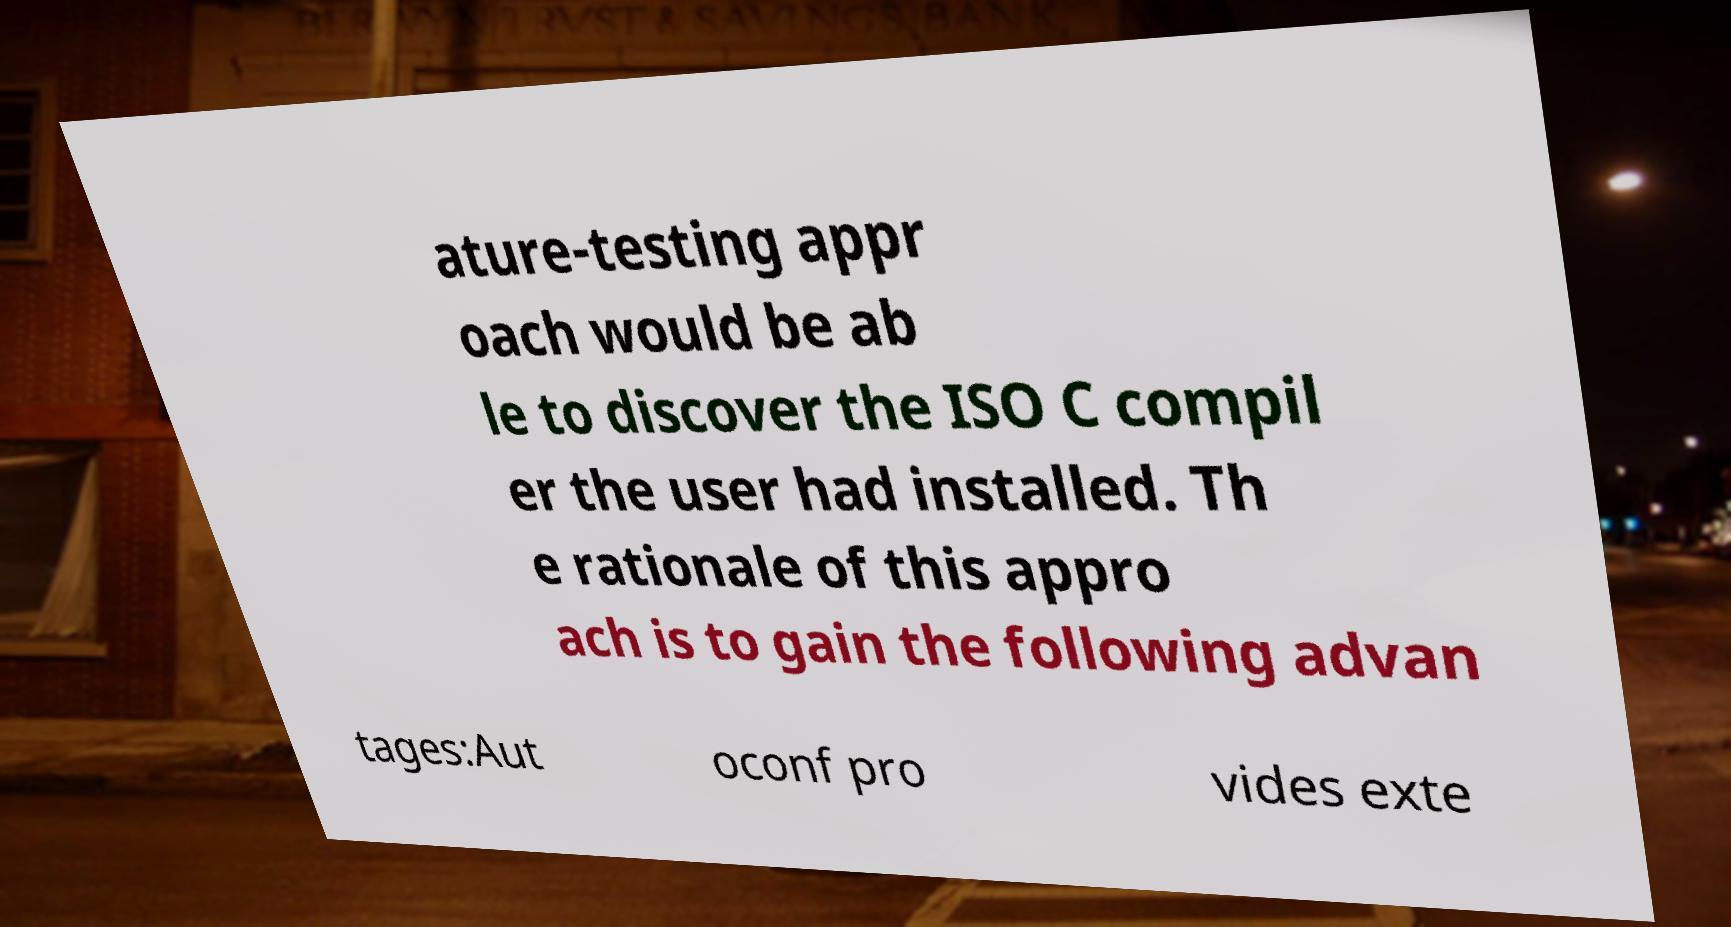Could you extract and type out the text from this image? ature-testing appr oach would be ab le to discover the ISO C compil er the user had installed. Th e rationale of this appro ach is to gain the following advan tages:Aut oconf pro vides exte 